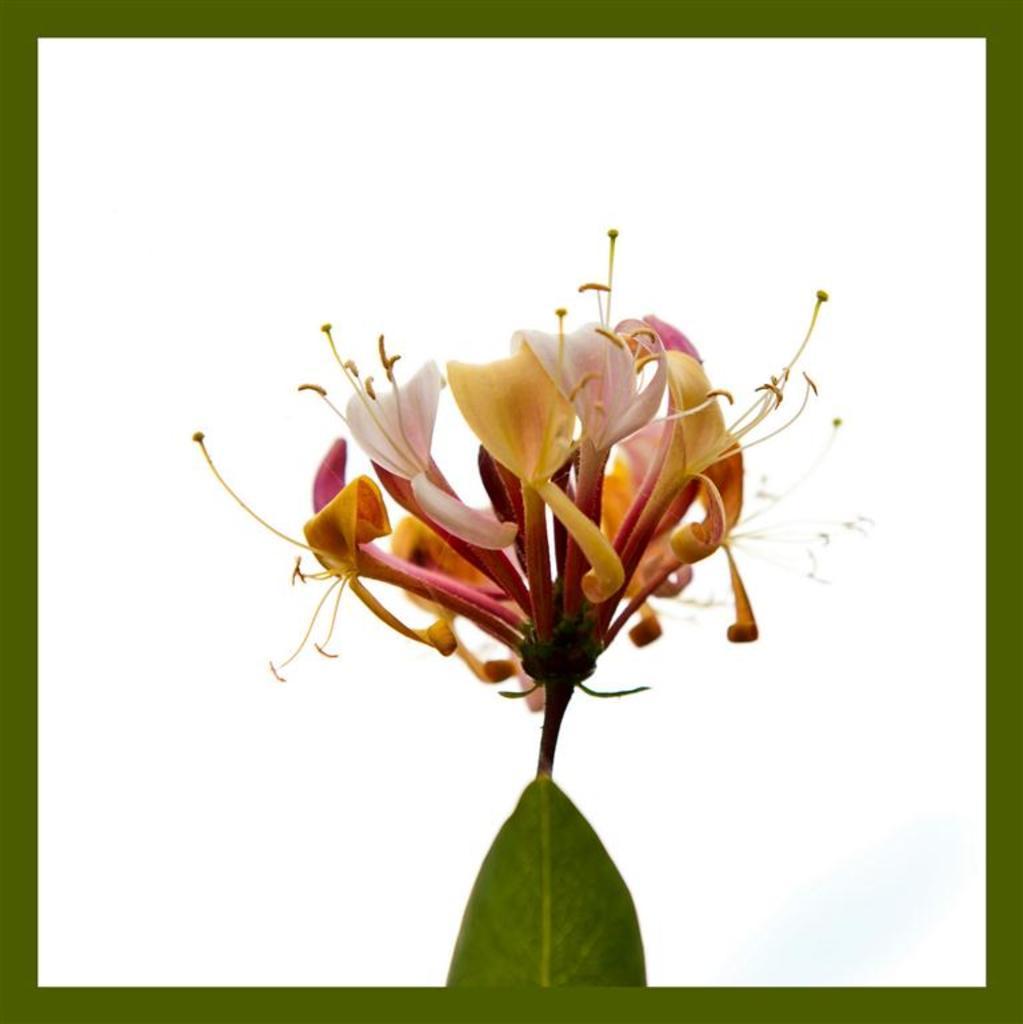Could you give a brief overview of what you see in this image? In this image in the front there is a flower and there is a leaf. 